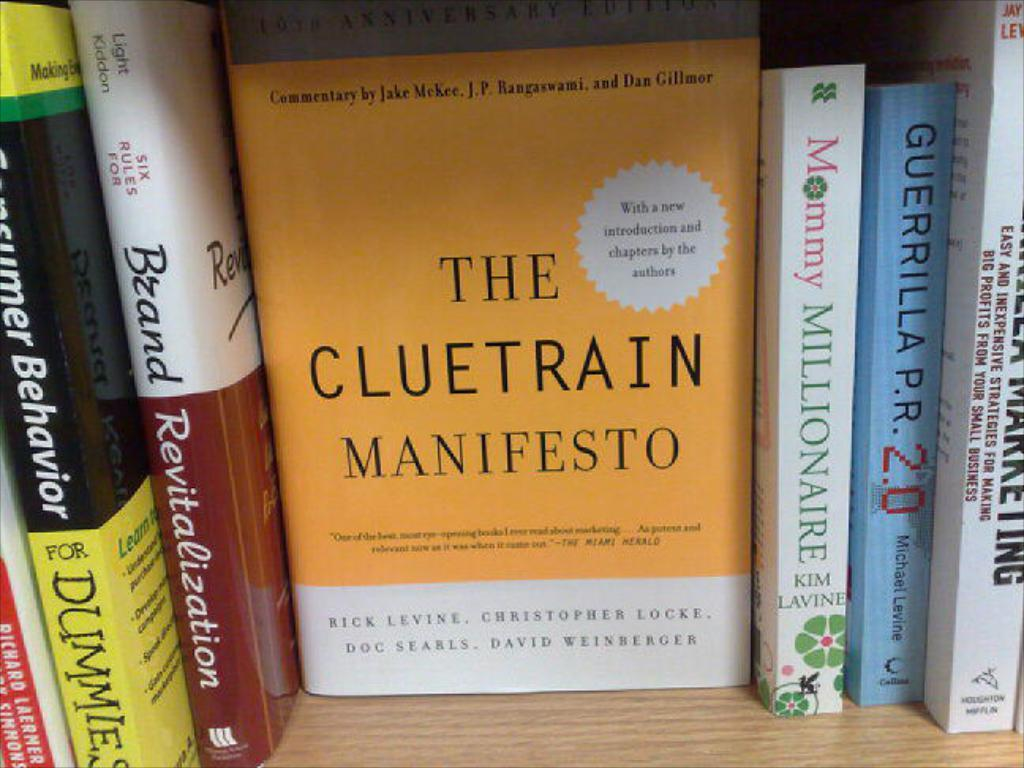<image>
Render a clear and concise summary of the photo. The Cluetrain Manifesto is on the book shelf next to Mommy Millionaire. 